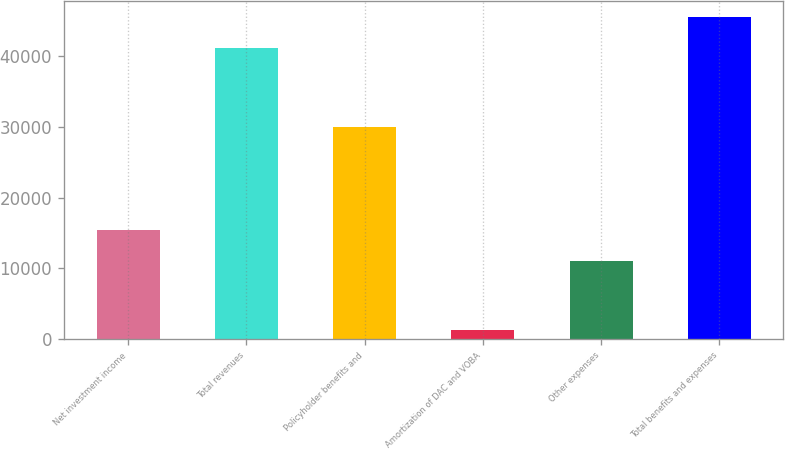Convert chart. <chart><loc_0><loc_0><loc_500><loc_500><bar_chart><fcel>Net investment income<fcel>Total revenues<fcel>Policyholder benefits and<fcel>Amortization of DAC and VOBA<fcel>Other expenses<fcel>Total benefits and expenses<nl><fcel>15469.4<fcel>41058<fcel>29986<fcel>1307<fcel>11061<fcel>45466.4<nl></chart> 